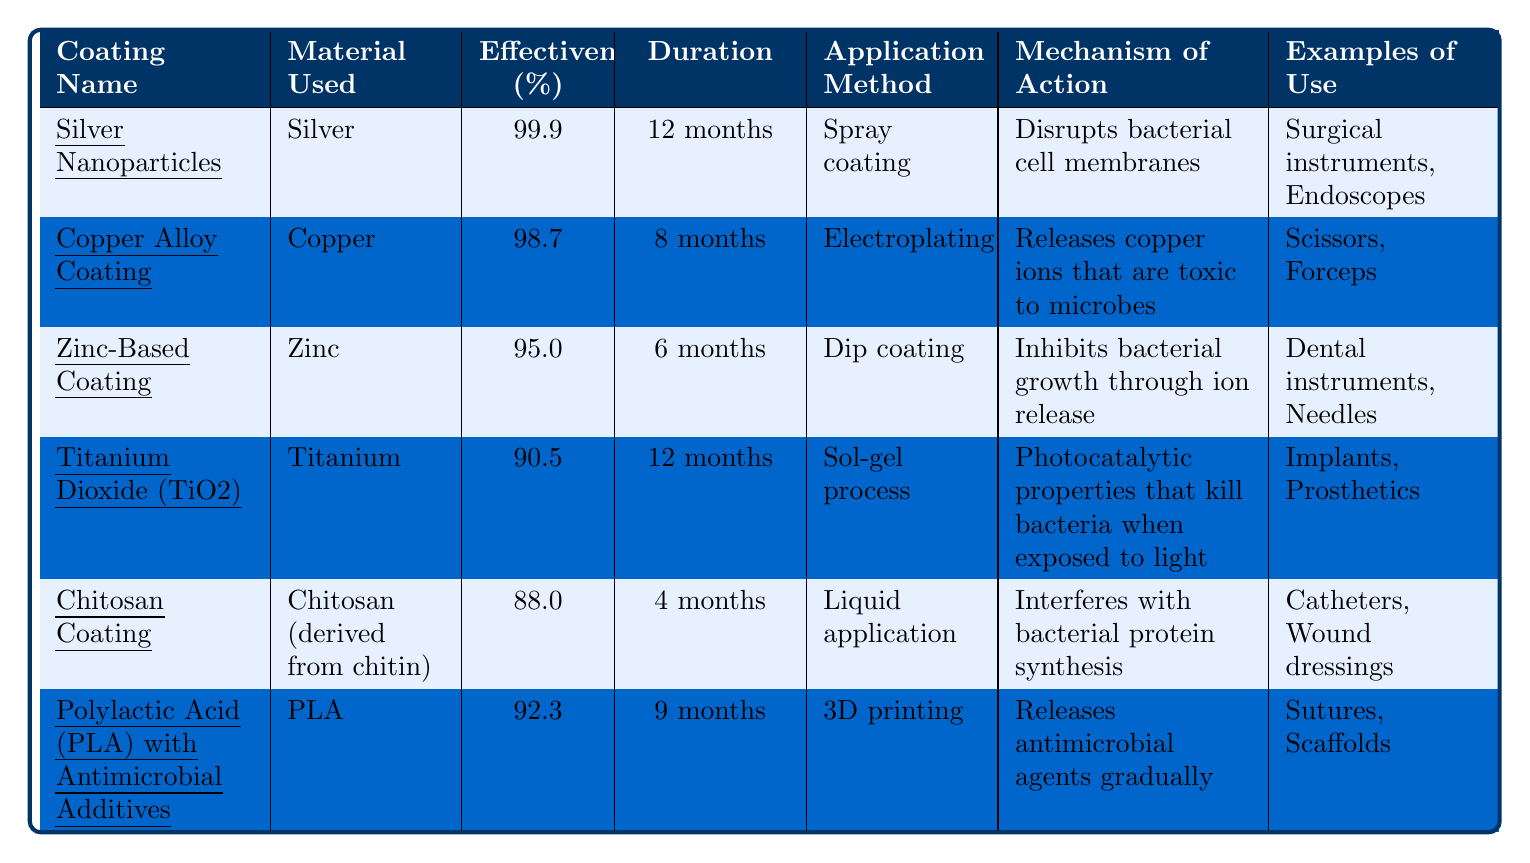What is the effectiveness percentage of Silver Nanoparticles? The table lists the effectiveness percentage for Silver Nanoparticles as 99.9%.
Answer: 99.9% How long does the Copper Alloy Coating last? The duration of effectiveness for Copper Alloy Coating as indicated in the table is 8 months.
Answer: 8 months Which coating has the longest duration of effectiveness? By comparing the durations listed, Silver Nanoparticles and Titanium Dioxide both have a duration of 12 months, which is the longest among all coatings.
Answer: Silver Nanoparticles and Titanium Dioxide Is Chitosan Coating more effective than Zinc-Based Coating? The effectiveness percentage of Chitosan Coating is 88.0%, while Zinc-Based Coating has an effectiveness of 95.0%. Since 88.0% is less than 95.0%, Chitosan Coating is not more effective.
Answer: No What is the average effectiveness percentage of all coatings listed in the table? To find the average, we sum the effectiveness percentages: 99.9 + 98.7 + 95.0 + 90.5 + 88.0 + 92.3 = 564.4. There are 6 coatings, so we divide: 564.4 / 6 ≈ 94.07.
Answer: 94.07 Which coating uses the material derived from chitin? The table indicates that Chitosan Coating is derived from chitin, as per its description.
Answer: Chitosan Coating What application method is used for Polylactic Acid (PLA) with Antimicrobial Additives? The application method for PLA with Antimicrobial Additives is 3D printing, as stated in the table.
Answer: 3D printing If you need a coating that lasts at least 9 months, which coatings are available? Silver Nanoparticles and Titanium Dioxide both have durations of effectiveness of 12 months, while Polylactic Acid (PLA) lasts for 9 months, making these three options viable for at least 9 months.
Answer: Silver Nanoparticles, Titanium Dioxide, Polylactic Acid (PLA) What mechanisms of action do the coatings have in common? The table shows that all coatings aim to inhibit or disrupt microbial activity, but the specific mechanisms vary (e.g., some disrupt cell membranes, others release toxic ions). The commonality is their goal of providing antimicrobial action.
Answer: They all aim to inhibit/disrupt microbial activity Which coating is applied using the dip coating method? The table specifies that Zinc-Based Coating uses the dip coating application method.
Answer: Zinc-Based Coating 